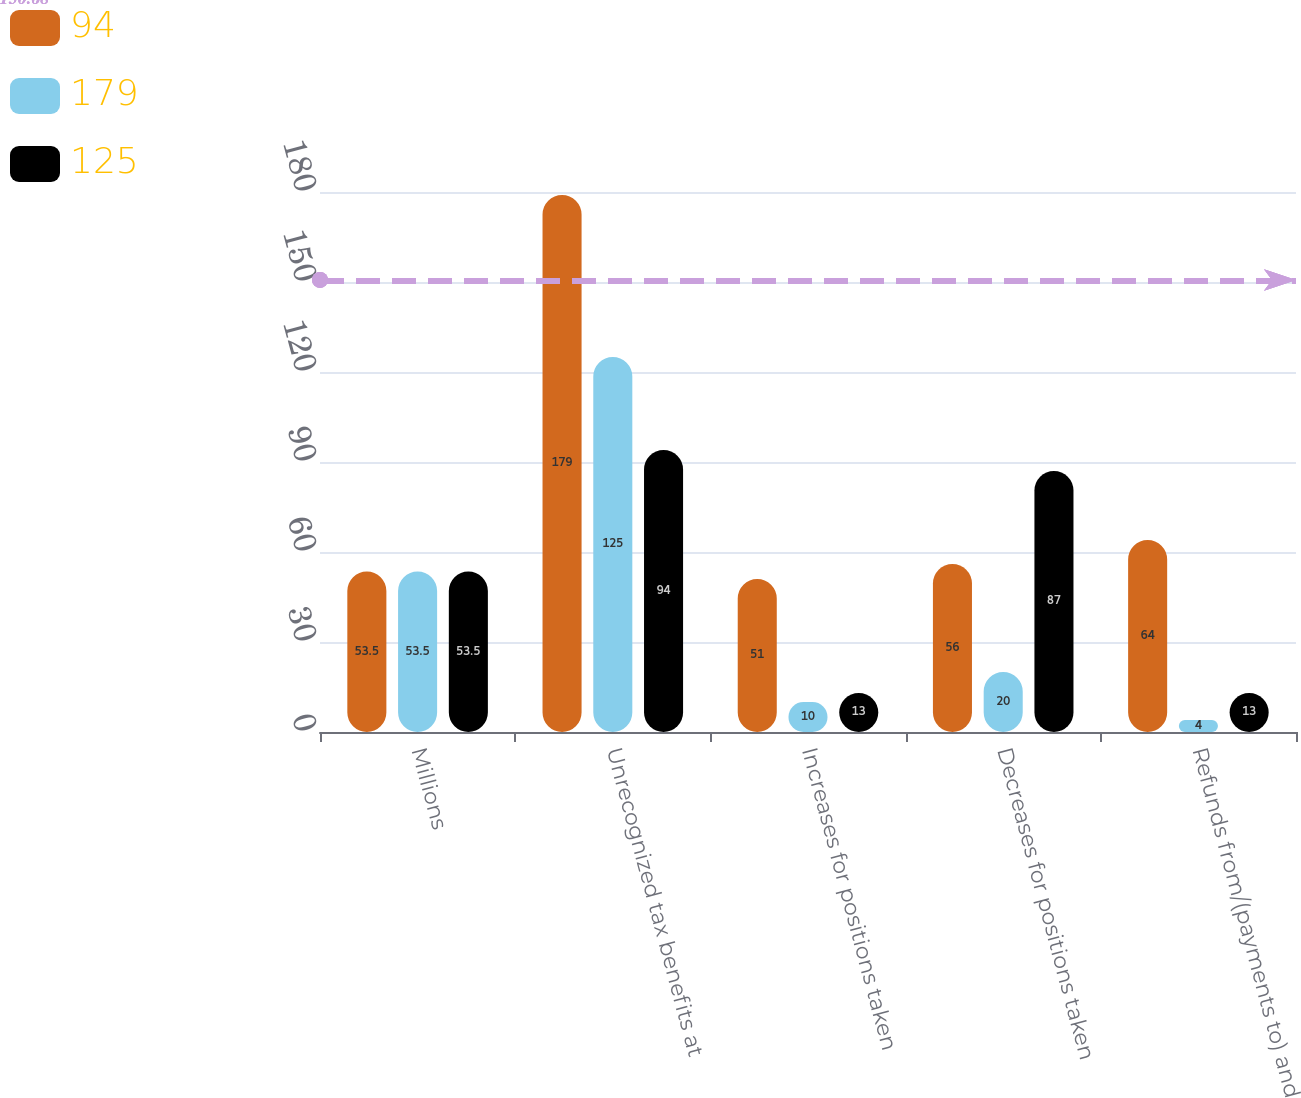Convert chart to OTSL. <chart><loc_0><loc_0><loc_500><loc_500><stacked_bar_chart><ecel><fcel>Millions<fcel>Unrecognized tax benefits at<fcel>Increases for positions taken<fcel>Decreases for positions taken<fcel>Refunds from/(payments to) and<nl><fcel>94<fcel>53.5<fcel>179<fcel>51<fcel>56<fcel>64<nl><fcel>179<fcel>53.5<fcel>125<fcel>10<fcel>20<fcel>4<nl><fcel>125<fcel>53.5<fcel>94<fcel>13<fcel>87<fcel>13<nl></chart> 